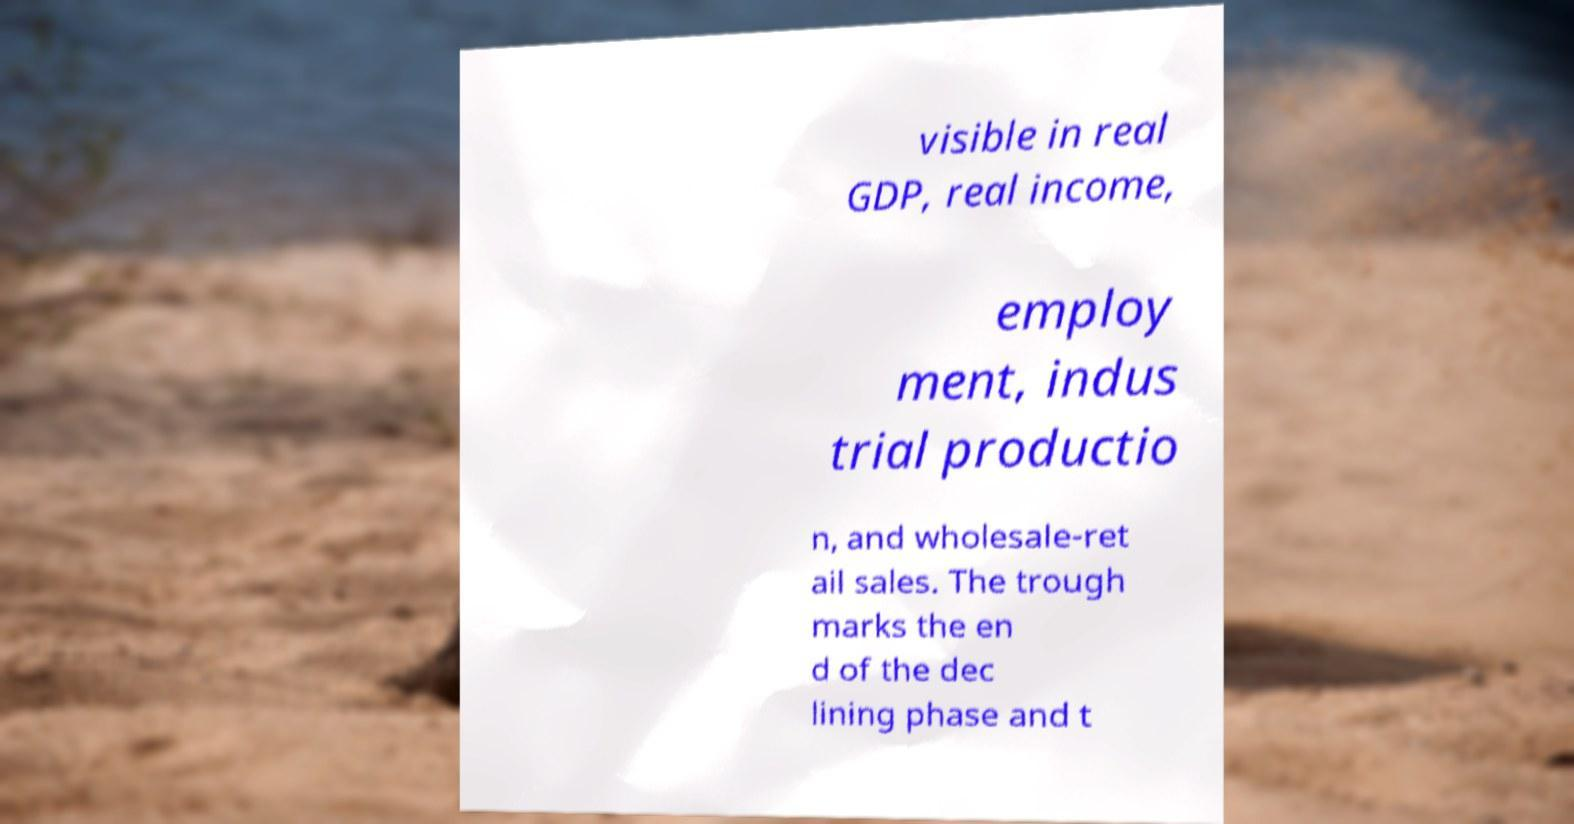For documentation purposes, I need the text within this image transcribed. Could you provide that? visible in real GDP, real income, employ ment, indus trial productio n, and wholesale-ret ail sales. The trough marks the en d of the dec lining phase and t 